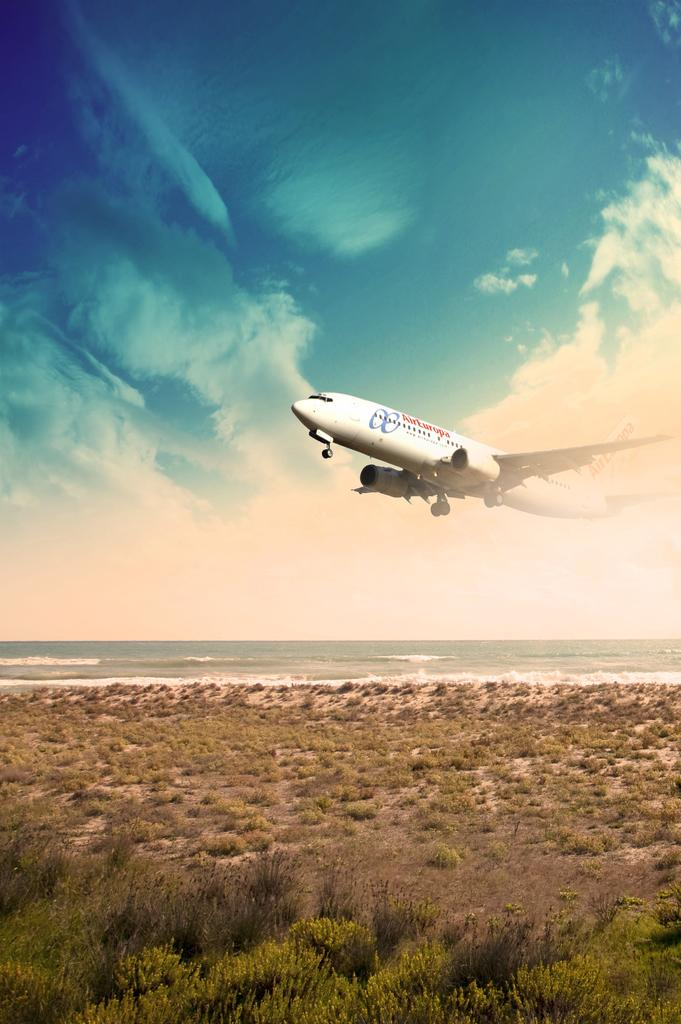What is the main subject of the image? The main subject of the image is an aircraft. Where is the aircraft located in the image? The aircraft is in the air in the image. What can be seen on the ground in the image? There are plants on the ground in the image. What is the color of the sky in the image? The sky is blue and visible at the top of the image. What type of cloth is draped over the deer in the image? There is no deer or cloth present in the image; it features an aircraft in the air and plants on the ground. 